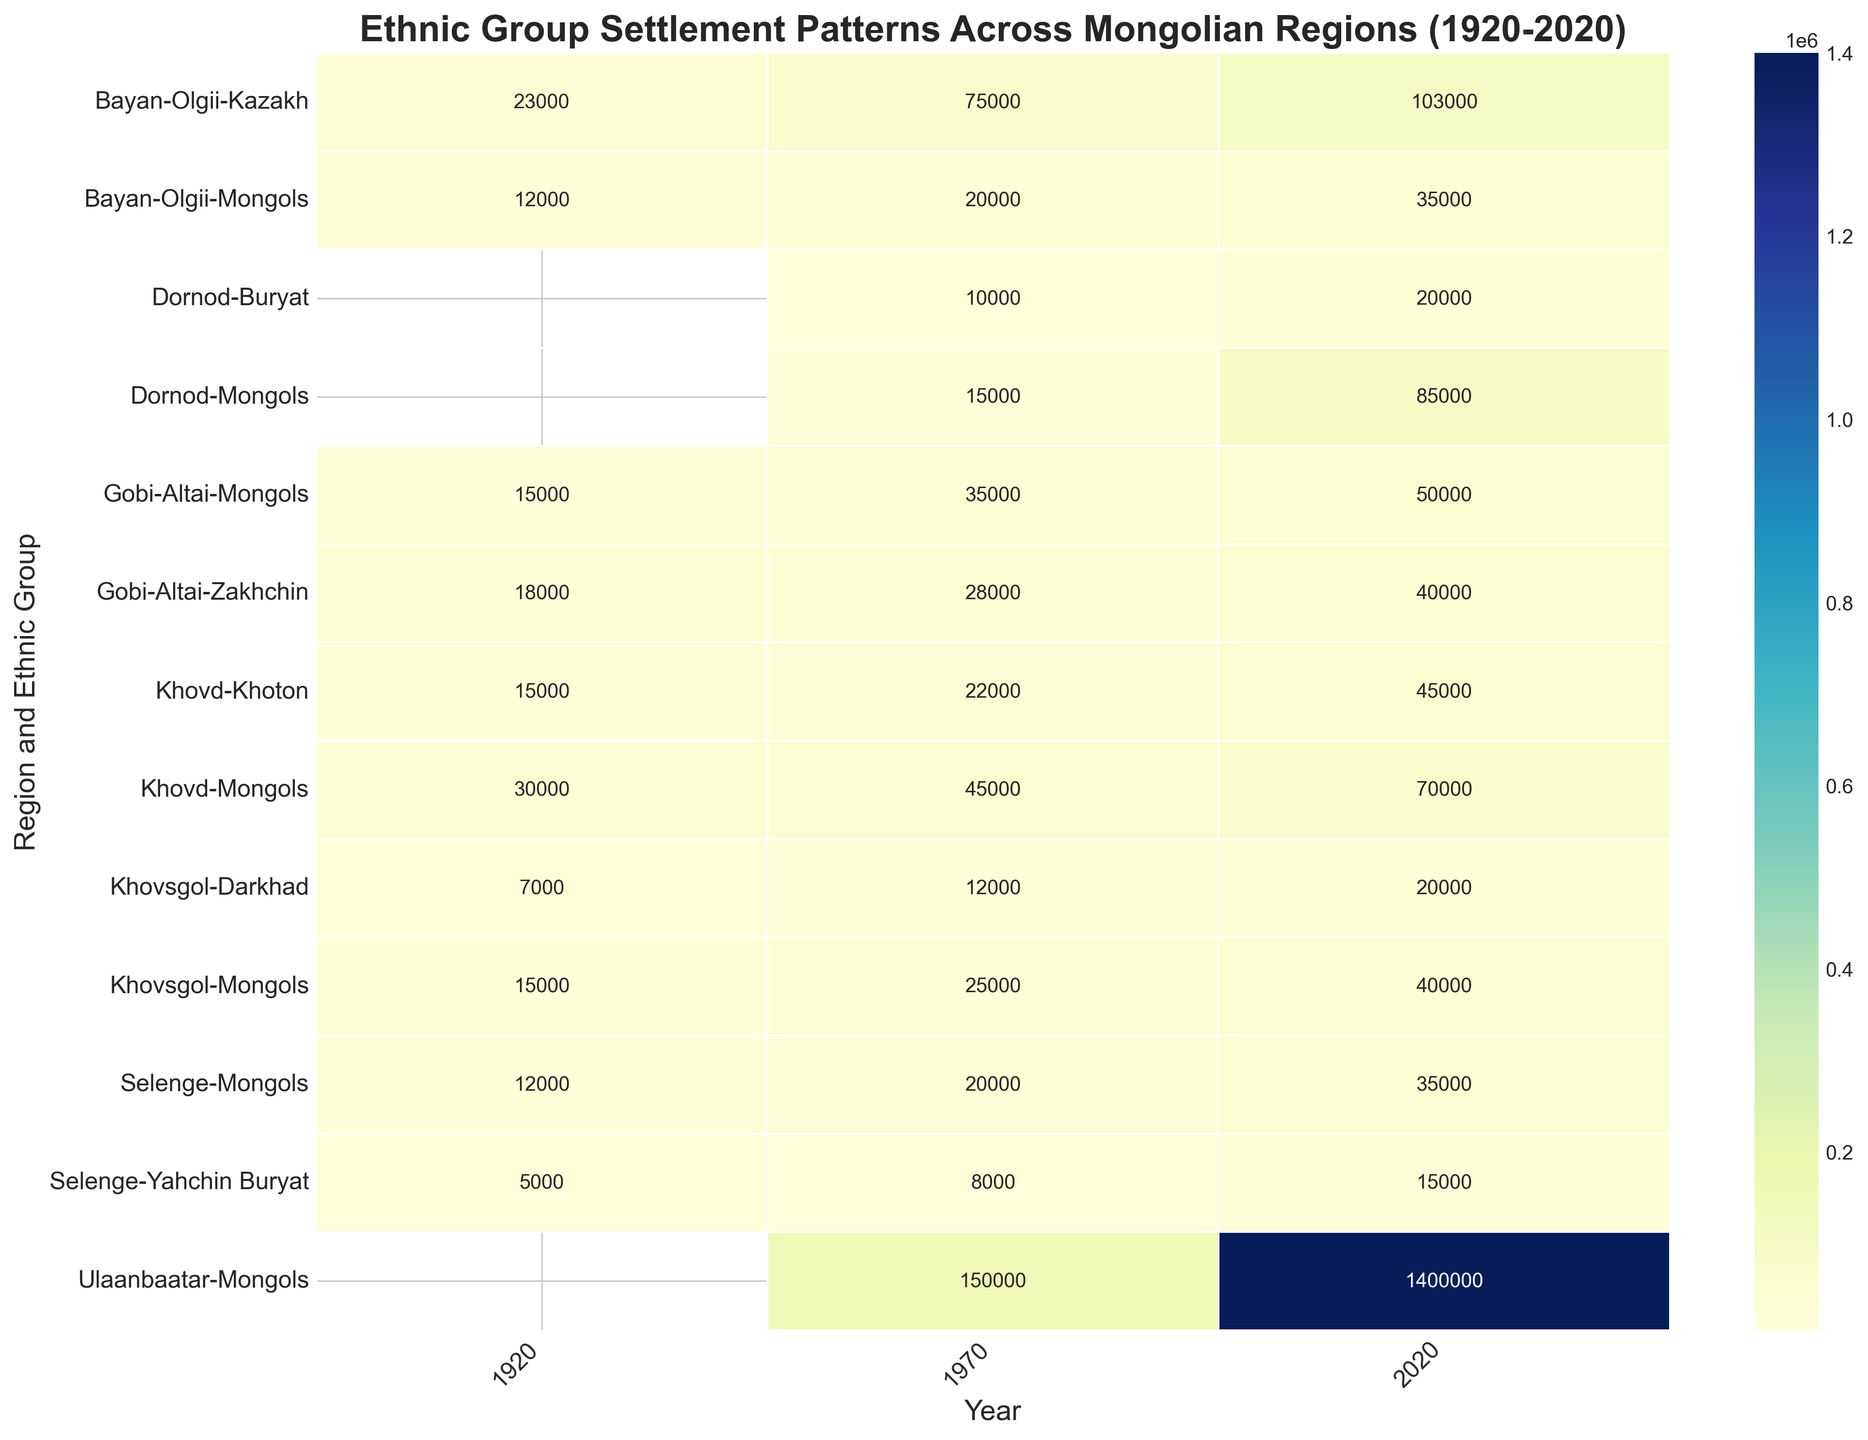What is the population growth of the Kazakh ethnic group in Bayan-Olgii from 1920 to 2020? Look at the heatmap for the Kazakh population in Bayan-Olgii in 1920 and 2020. The values are 23,000 in 1920 and 103,000 in 2020. Subtract the population in 1920 from the population in 2020 (103,000 - 23,000 = 80,000).
Answer: 80,000 Which ethnic group had the smallest population in Selenge in 1970? Compare the population numbers for both ethnic groups in Selenge in 1970. Yahchin Buryat had 8,000, and Mongols had 20,000. Yahchin Buryat has the smaller population.
Answer: Yahchin Buryat How did the population of Mongols in Ulaanbaatar change from 1970 to 2020? Compare the Mongol population in Ulaanbaatar in 1970 to that in 2020, which are 150,000 and 1,400,000 respectively. Subtract the 1970 population from the 2020 population (1,400,000 - 150,000 = 1,250,000).
Answer: 1,250,000 Which region had the highest Zakhchin population in 2020? Compare the Zakhchin population in all listed regions in 2020. Gobi-Altai has 40,000.
Answer: Gobi-Altai What is the total population of Mongols across all regions in 1920? Sum the Mongol population across all regions in 1920. Bayan-Olgii (12,000), Khovd (30,000), Gobi-Altai (15,000), Selenge (12,000), Khovsgol (15,000). The sum is (12,000 + 30,000 + 15,000 + 12,000 + 15,000 = 84,000).
Answer: 84,000 What was the population difference between Khoton and Kazakh in Khovd in 1970? Compare the populations of Khoton and Kazakh in Khovd in 1970. Khoton had 22,000 and Kazakh had 0. Subtract the two values (22,000 - 0 = 22,000).
Answer: 22,000 Which ethnic group experienced the highest percentage increase in Gobi-Altai from 1920 to 2020? For Zakhchin, the population increased from 18,000 to 40,000 (22,000 increase). For Mongols, the population increased from 15,000 to 50,000 (35,000 increase). Calculate the percentage increase: Zakhchin (22,000/18,000 ≈ 122.22%) vs Mongols (35,000/15,000 ≈ 233.33%). Mongols have the highest percentage increase.
Answer: Mongols Which region had the largest ethnic diversity in terms of distinct groups in 2020? Look at the number of distinct ethnic groups listed per region in 2020. Bayan-Olgii has Kazakh and Mongols (2 distinct groups). Khovd has Khoton and Mongols (2), Ulaanbaatar has only Mongols (1), Dornod has Buryat and Mongols (2), Gobi-Altai has Zakhchin and Mongols (2), and Selenge has Yahchin Buryat and Mongols (2), Khovsgol has Darkhad and Mongols (2). All except Ulaanbaatar have 2 distinct groups, so draw the conclusion.
Answer: Bayan-Olgii, Khovd, Dornod, Gobi-Altai, Selenge, Khovsgol How did the population of Buryat in Dornod change from 1970 to 2020? Compare the Buryat population in Dornod in 1970 (10,000) to that in 2020 (20,000). Subtract the 1970 population from the 2020 population (20,000 - 10,000 = 10,000).
Answer: 10,000 